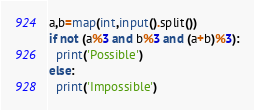Convert code to text. <code><loc_0><loc_0><loc_500><loc_500><_Python_>a,b=map(int,input().split())
if not (a%3 and b%3 and (a+b)%3):
  print('Possible')
else:
  print('Impossible')
</code> 